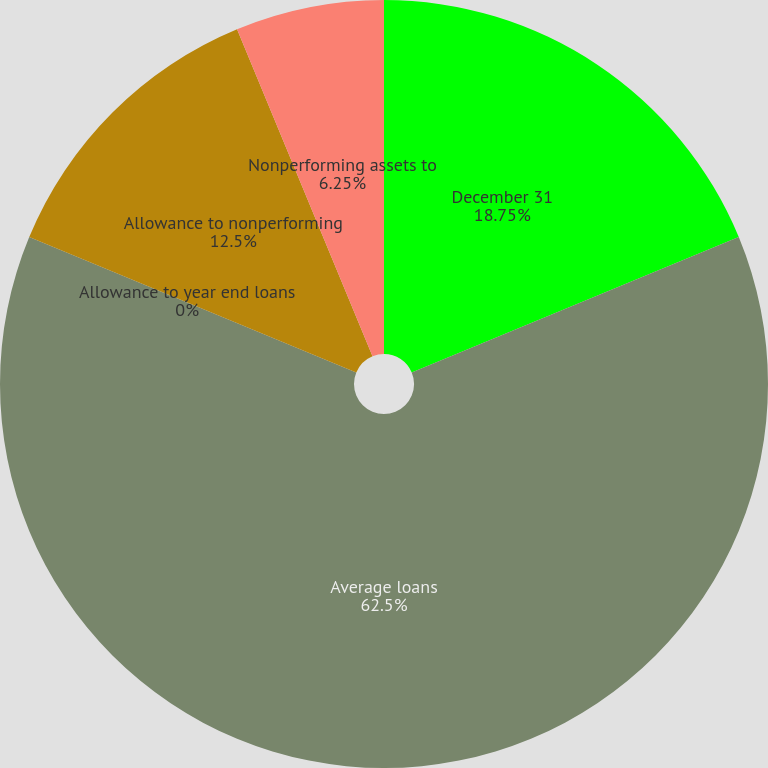<chart> <loc_0><loc_0><loc_500><loc_500><pie_chart><fcel>December 31<fcel>Average loans<fcel>Allowance to year end loans<fcel>Allowance to nonperforming<fcel>Nonperforming assets to<nl><fcel>18.75%<fcel>62.5%<fcel>0.0%<fcel>12.5%<fcel>6.25%<nl></chart> 